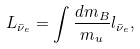Convert formula to latex. <formula><loc_0><loc_0><loc_500><loc_500>L _ { \bar { \nu } _ { e } } = \int \frac { d m _ { B } } { m _ { u } } l _ { \bar { \nu } _ { e } } ,</formula> 